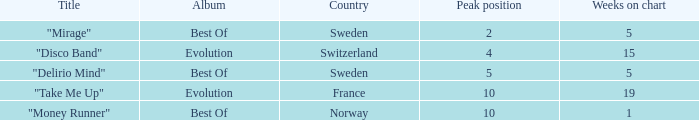Can you give me this table as a dict? {'header': ['Title', 'Album', 'Country', 'Peak position', 'Weeks on chart'], 'rows': [['"Mirage"', 'Best Of', 'Sweden', '2', '5'], ['"Disco Band"', 'Evolution', 'Switzerland', '4', '15'], ['"Delirio Mind"', 'Best Of', 'Sweden', '5', '5'], ['"Take Me Up"', 'Evolution', 'France', '10', '19'], ['"Money Runner"', 'Best Of', 'Norway', '10', '1']]} What is the title of the single with the peak position of 10 and from France? "Take Me Up". 